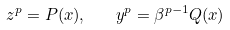Convert formula to latex. <formula><loc_0><loc_0><loc_500><loc_500>z ^ { p } = P ( x ) , \quad y ^ { p } = \beta ^ { p - 1 } Q ( x )</formula> 